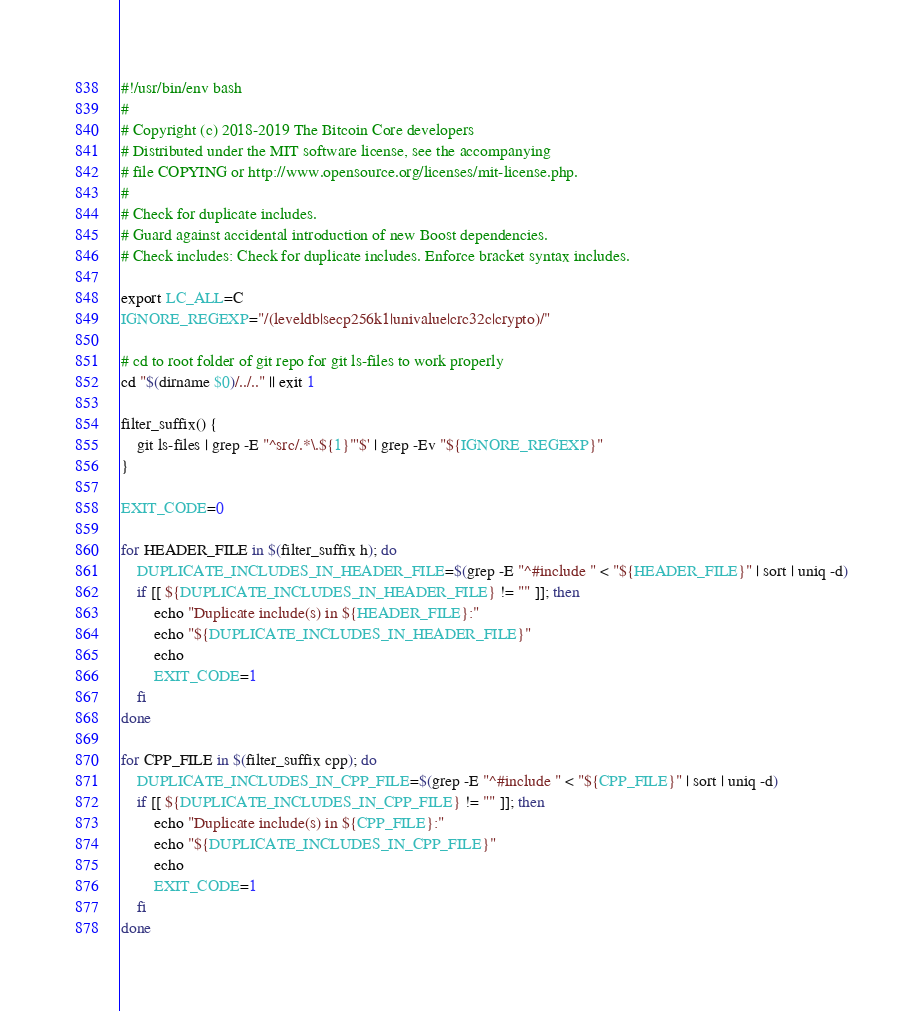Convert code to text. <code><loc_0><loc_0><loc_500><loc_500><_Bash_>#!/usr/bin/env bash
#
# Copyright (c) 2018-2019 The Bitcoin Core developers
# Distributed under the MIT software license, see the accompanying
# file COPYING or http://www.opensource.org/licenses/mit-license.php.
#
# Check for duplicate includes.
# Guard against accidental introduction of new Boost dependencies.
# Check includes: Check for duplicate includes. Enforce bracket syntax includes.

export LC_ALL=C
IGNORE_REGEXP="/(leveldb|secp256k1|univalue|crc32c|crypto)/"

# cd to root folder of git repo for git ls-files to work properly
cd "$(dirname $0)/../.." || exit 1

filter_suffix() {
    git ls-files | grep -E "^src/.*\.${1}"'$' | grep -Ev "${IGNORE_REGEXP}"
}

EXIT_CODE=0

for HEADER_FILE in $(filter_suffix h); do
    DUPLICATE_INCLUDES_IN_HEADER_FILE=$(grep -E "^#include " < "${HEADER_FILE}" | sort | uniq -d)
    if [[ ${DUPLICATE_INCLUDES_IN_HEADER_FILE} != "" ]]; then
        echo "Duplicate include(s) in ${HEADER_FILE}:"
        echo "${DUPLICATE_INCLUDES_IN_HEADER_FILE}"
        echo
        EXIT_CODE=1
    fi
done

for CPP_FILE in $(filter_suffix cpp); do
    DUPLICATE_INCLUDES_IN_CPP_FILE=$(grep -E "^#include " < "${CPP_FILE}" | sort | uniq -d)
    if [[ ${DUPLICATE_INCLUDES_IN_CPP_FILE} != "" ]]; then
        echo "Duplicate include(s) in ${CPP_FILE}:"
        echo "${DUPLICATE_INCLUDES_IN_CPP_FILE}"
        echo
        EXIT_CODE=1
    fi
done
</code> 